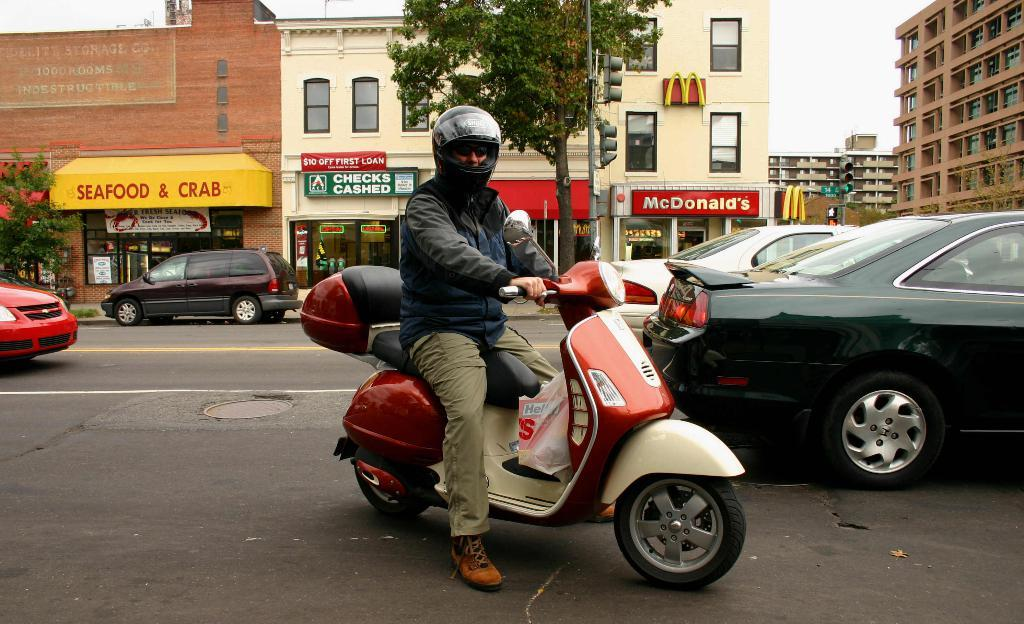What is the man in the image doing? The man is riding a Scooty in the image. What can be seen on the right side of the image? There are cars on the right side of the image. What is located in the middle of the image? There is a tree in the middle of the image. What type of vegetable is being used as a ring in the image? There is no vegetable or ring present in the image. 